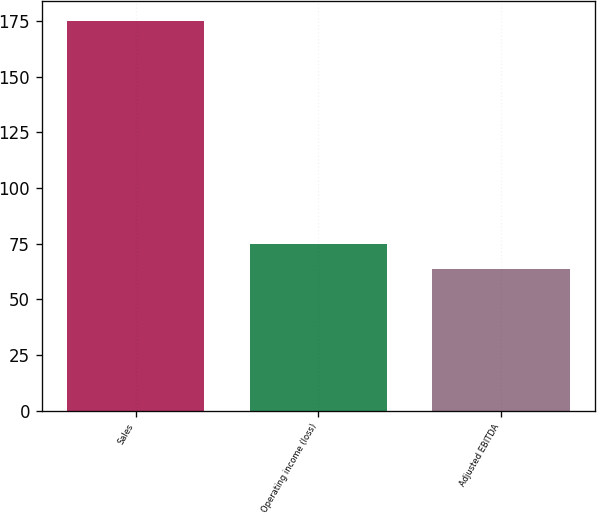Convert chart. <chart><loc_0><loc_0><loc_500><loc_500><bar_chart><fcel>Sales<fcel>Operating income (loss)<fcel>Adjusted EBITDA<nl><fcel>175.1<fcel>74.93<fcel>63.8<nl></chart> 